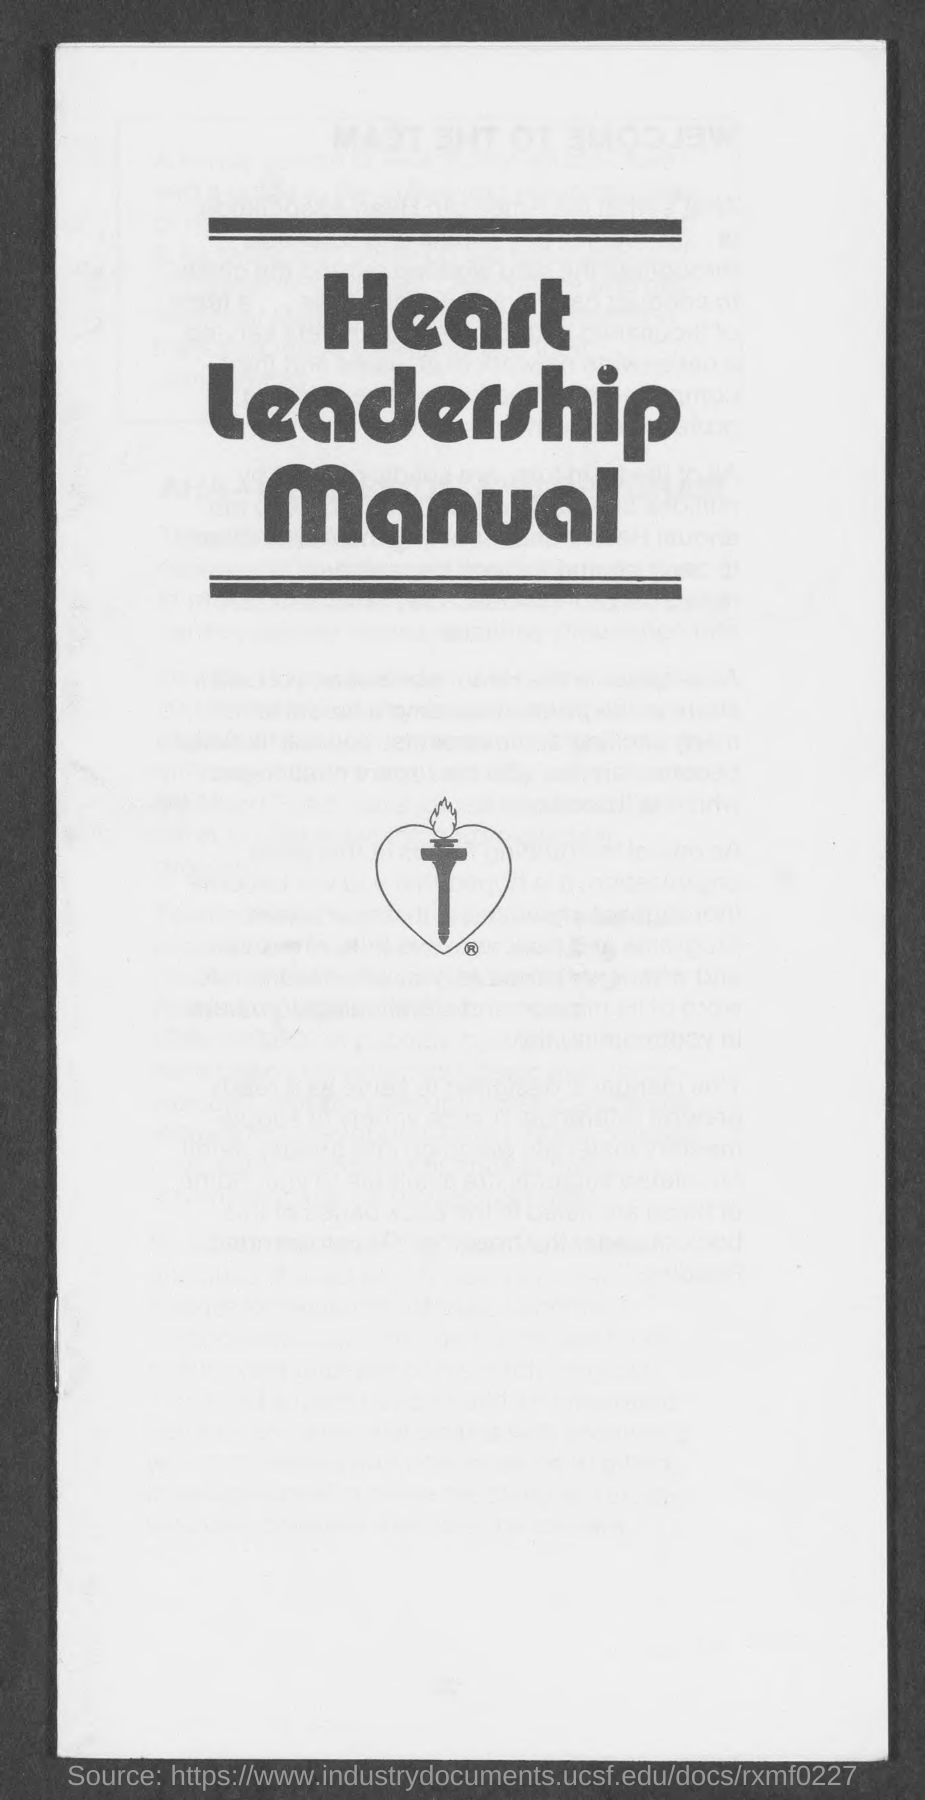Specify some key components in this picture. The title of the manual is the Heart Leadership manual. 